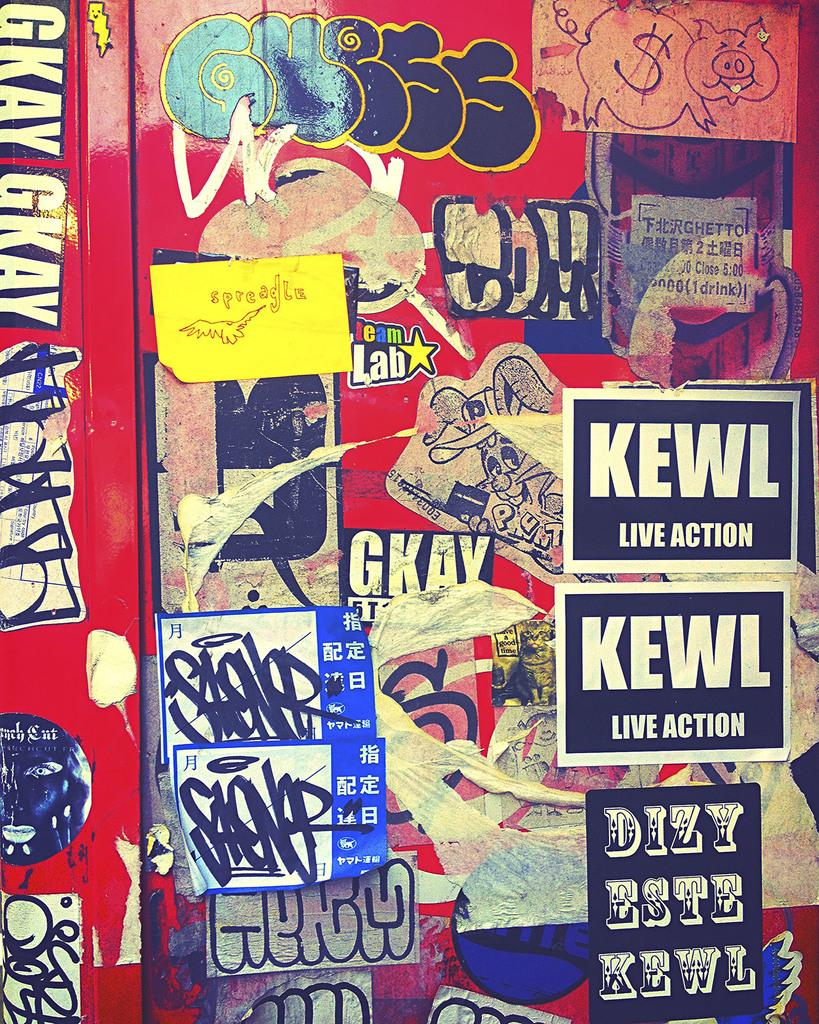Provide a one-sentence caption for the provided image. Stickers on a wall with one that says KEWL. 